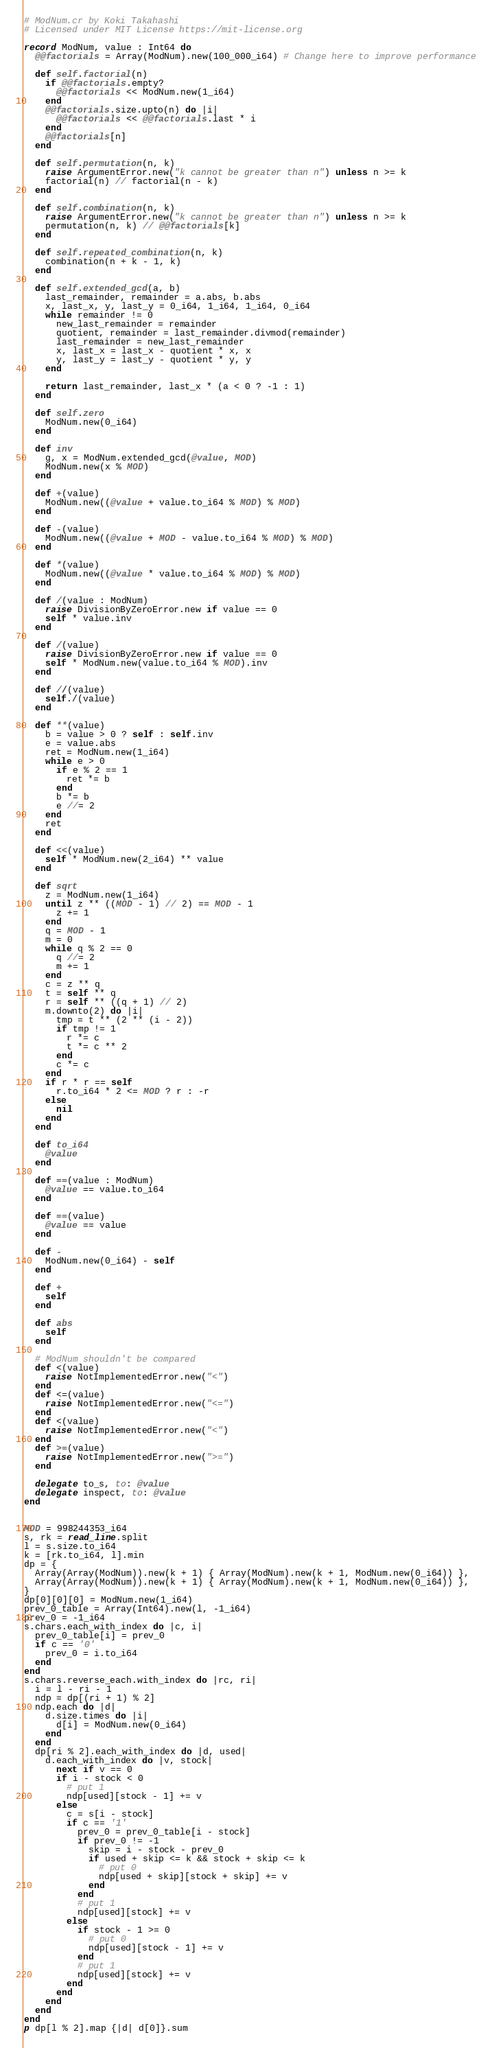<code> <loc_0><loc_0><loc_500><loc_500><_Crystal_># ModNum.cr by Koki Takahashi
# Licensed under MIT License https://mit-license.org

record ModNum, value : Int64 do
  @@factorials = Array(ModNum).new(100_000_i64) # Change here to improve performance

  def self.factorial(n)
    if @@factorials.empty?
      @@factorials << ModNum.new(1_i64)
    end
    @@factorials.size.upto(n) do |i|
      @@factorials << @@factorials.last * i
    end
    @@factorials[n]
  end

  def self.permutation(n, k)
    raise ArgumentError.new("k cannot be greater than n") unless n >= k
    factorial(n) // factorial(n - k)
  end

  def self.combination(n, k)
    raise ArgumentError.new("k cannot be greater than n") unless n >= k
    permutation(n, k) // @@factorials[k]
  end

  def self.repeated_combination(n, k)
    combination(n + k - 1, k)
  end

  def self.extended_gcd(a, b)
    last_remainder, remainder = a.abs, b.abs
    x, last_x, y, last_y = 0_i64, 1_i64, 1_i64, 0_i64
    while remainder != 0
      new_last_remainder = remainder
      quotient, remainder = last_remainder.divmod(remainder)
      last_remainder = new_last_remainder
      x, last_x = last_x - quotient * x, x
      y, last_y = last_y - quotient * y, y
    end

    return last_remainder, last_x * (a < 0 ? -1 : 1)
  end

  def self.zero
    ModNum.new(0_i64)
  end

  def inv
    g, x = ModNum.extended_gcd(@value, MOD)
    ModNum.new(x % MOD)
  end

  def +(value)
    ModNum.new((@value + value.to_i64 % MOD) % MOD)
  end

  def -(value)
    ModNum.new((@value + MOD - value.to_i64 % MOD) % MOD)
  end

  def *(value)
    ModNum.new((@value * value.to_i64 % MOD) % MOD)
  end

  def /(value : ModNum)
    raise DivisionByZeroError.new if value == 0
    self * value.inv
  end

  def /(value)
    raise DivisionByZeroError.new if value == 0
    self * ModNum.new(value.to_i64 % MOD).inv
  end

  def //(value)
    self./(value)
  end

  def **(value)
    b = value > 0 ? self : self.inv
    e = value.abs
    ret = ModNum.new(1_i64)
    while e > 0
      if e % 2 == 1
        ret *= b
      end
      b *= b
      e //= 2
    end
    ret
  end

  def <<(value)
    self * ModNum.new(2_i64) ** value
  end

  def sqrt
    z = ModNum.new(1_i64)
    until z ** ((MOD - 1) // 2) == MOD - 1
      z += 1
    end
    q = MOD - 1
    m = 0
    while q % 2 == 0
      q //= 2
      m += 1
    end
    c = z ** q
    t = self ** q
    r = self ** ((q + 1) // 2)
    m.downto(2) do |i|
      tmp = t ** (2 ** (i - 2))
      if tmp != 1
        r *= c
        t *= c ** 2
      end
      c *= c
    end
    if r * r == self
      r.to_i64 * 2 <= MOD ? r : -r
    else
      nil
    end
  end

  def to_i64
    @value
  end

  def ==(value : ModNum)
    @value == value.to_i64
  end

  def ==(value)
    @value == value
  end

  def -
    ModNum.new(0_i64) - self
  end

  def +
    self
  end

  def abs
    self
  end

  # ModNum shouldn't be compared
  def <(value)
    raise NotImplementedError.new("<")
  end
  def <=(value)
    raise NotImplementedError.new("<=")
  end
  def <(value)
    raise NotImplementedError.new("<")
  end
  def >=(value)
    raise NotImplementedError.new(">=")
  end

  delegate to_s, to: @value
  delegate inspect, to: @value
end


MOD = 998244353_i64
s, rk = read_line.split
l = s.size.to_i64
k = [rk.to_i64, l].min
dp = {
  Array(Array(ModNum)).new(k + 1) { Array(ModNum).new(k + 1, ModNum.new(0_i64)) },
  Array(Array(ModNum)).new(k + 1) { Array(ModNum).new(k + 1, ModNum.new(0_i64)) },
}
dp[0][0][0] = ModNum.new(1_i64)
prev_0_table = Array(Int64).new(l, -1_i64)
prev_0 = -1_i64
s.chars.each_with_index do |c, i|
  prev_0_table[i] = prev_0
  if c == '0'
    prev_0 = i.to_i64
  end
end
s.chars.reverse_each.with_index do |rc, ri|
  i = l - ri - 1
  ndp = dp[(ri + 1) % 2]
  ndp.each do |d|
    d.size.times do |i|
      d[i] = ModNum.new(0_i64)
    end
  end
  dp[ri % 2].each_with_index do |d, used|
    d.each_with_index do |v, stock|
      next if v == 0
      if i - stock < 0
        # put 1
        ndp[used][stock - 1] += v
      else
        c = s[i - stock]
        if c == '1'
          prev_0 = prev_0_table[i - stock]
          if prev_0 != -1
            skip = i - stock - prev_0
            if used + skip <= k && stock + skip <= k
              # put 0
              ndp[used + skip][stock + skip] += v
            end
          end
          # put 1
          ndp[used][stock] += v
        else
          if stock - 1 >= 0
            # put 0
            ndp[used][stock - 1] += v
          end
          # put 1
          ndp[used][stock] += v
        end
      end
    end
  end
end
p dp[l % 2].map {|d| d[0]}.sum
</code> 